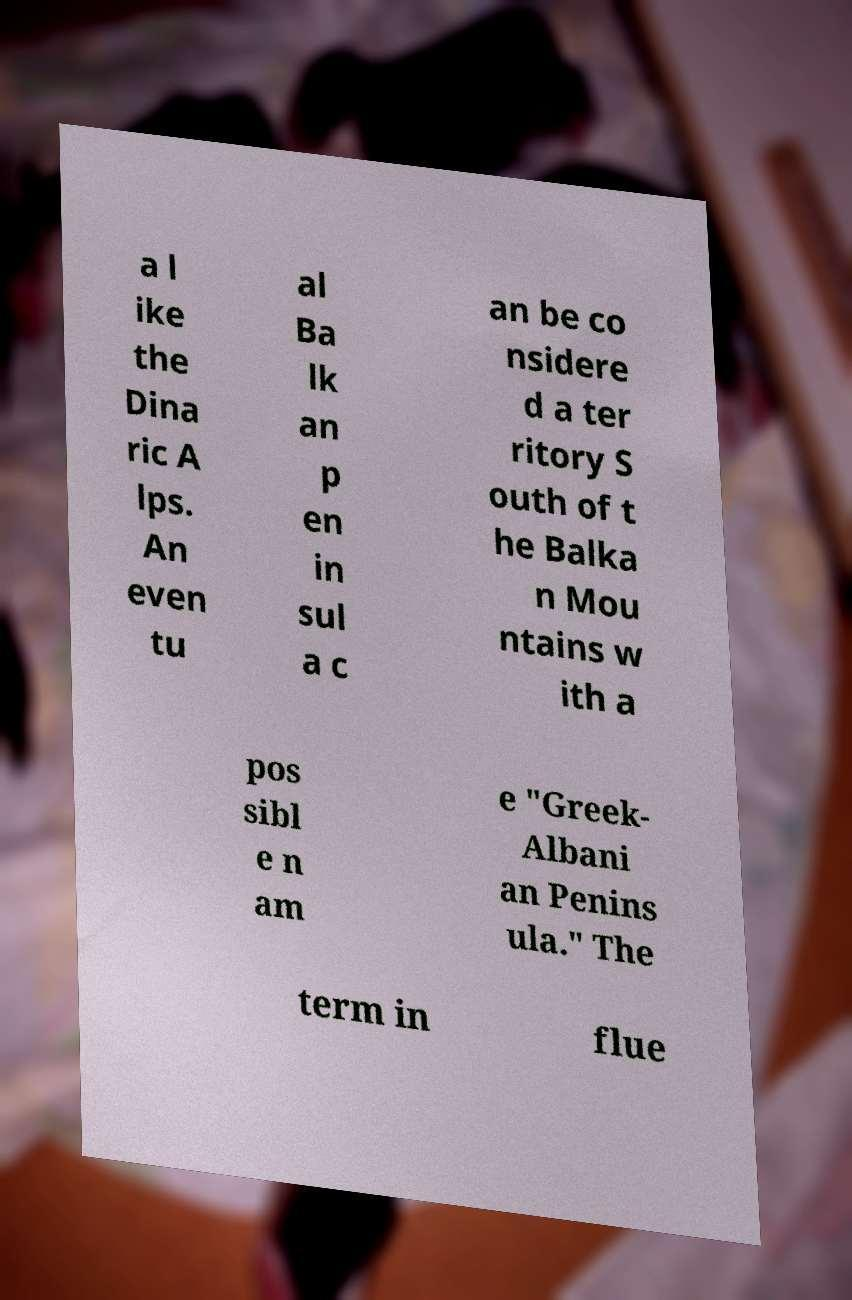Please identify and transcribe the text found in this image. a l ike the Dina ric A lps. An even tu al Ba lk an p en in sul a c an be co nsidere d a ter ritory S outh of t he Balka n Mou ntains w ith a pos sibl e n am e "Greek- Albani an Penins ula." The term in flue 